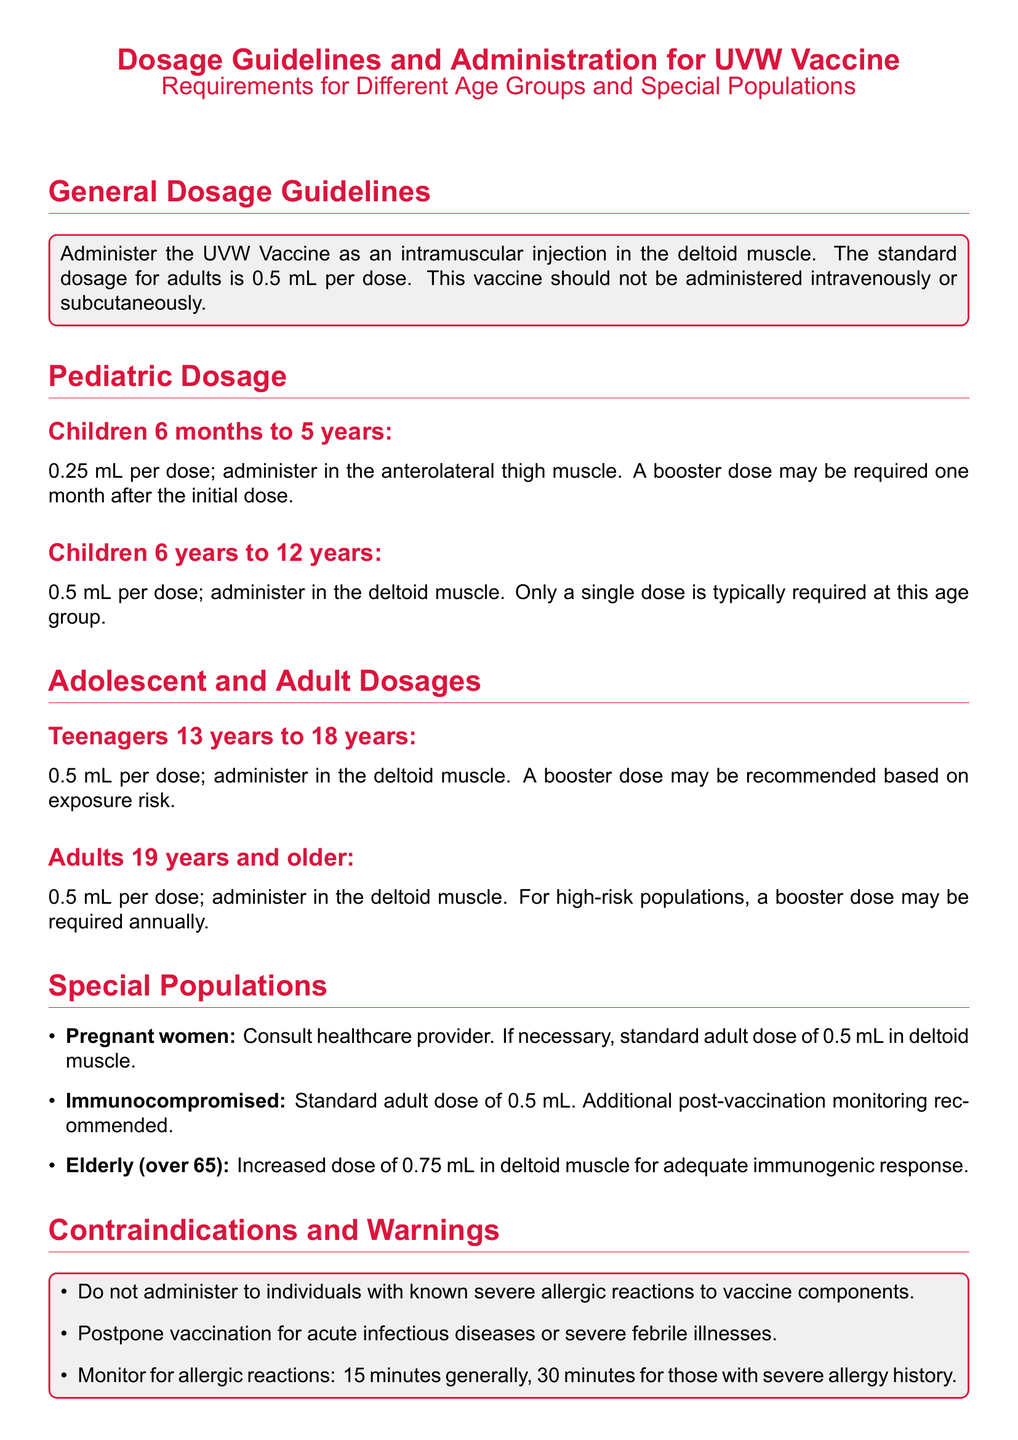What is the standard dosage for adults? The document states that the standard dosage for adults is 0.5 mL per dose.
Answer: 0.5 mL What is the dosage for children aged 6 months to 5 years? The document specifies that the dosage for children aged 6 months to 5 years is 0.25 mL per dose.
Answer: 0.25 mL How should the UVW Vaccine be administered for teenagers? The document indicates that teenagers should receive 0.5 mL per dose administered in the deltoid muscle.
Answer: 0.5 mL, deltoid muscle What is the recommended dosage for elderly individuals? The document states that elderly individuals should receive an increased dose of 0.75 mL.
Answer: 0.75 mL What should be done for pregnant women before vaccination? The document advises to consult a healthcare provider before vaccination for pregnant women.
Answer: Consult healthcare provider How long should individuals with a severe allergy history be monitored after vaccination? The document notes that individuals with a severe allergy history should be monitored for 30 minutes.
Answer: 30 minutes What is the storage temperature range for the UVW Vaccine? The document specifies that the vaccine should be stored at 2°C to 8°C.
Answer: 2°C to 8°C What is the booster dose recommendation for adults in high-risk populations? The document mentions that a booster dose may be required annually for adults in high-risk populations.
Answer: Annually What is the reason for postponing vaccination according to the document? The document states that vaccination should be postponed for acute infectious diseases or severe febrile illnesses.
Answer: Acute infectious diseases, severe febrile illnesses What should healthcare providers do regarding adverse events post-vaccination? The document instructs healthcare providers to report adverse events to the Vaccine Adverse Event Reporting System (VAERS).
Answer: Report to VAERS 